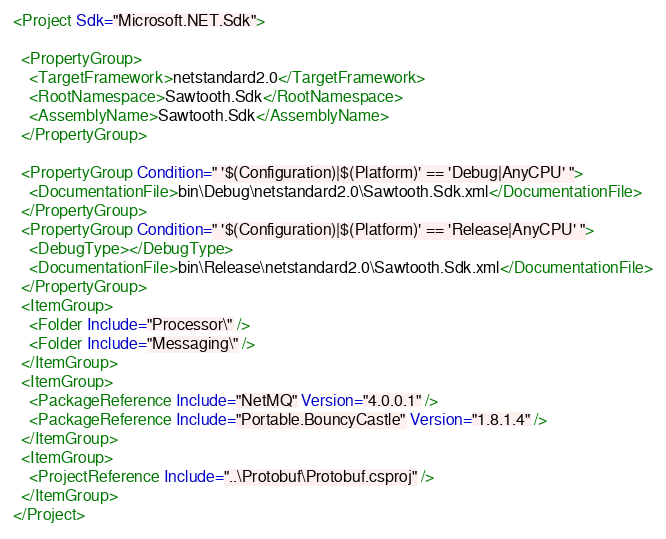<code> <loc_0><loc_0><loc_500><loc_500><_XML_><Project Sdk="Microsoft.NET.Sdk">

  <PropertyGroup>
    <TargetFramework>netstandard2.0</TargetFramework>
    <RootNamespace>Sawtooth.Sdk</RootNamespace>
    <AssemblyName>Sawtooth.Sdk</AssemblyName>
  </PropertyGroup>

  <PropertyGroup Condition=" '$(Configuration)|$(Platform)' == 'Debug|AnyCPU' ">
    <DocumentationFile>bin\Debug\netstandard2.0\Sawtooth.Sdk.xml</DocumentationFile>
  </PropertyGroup>
  <PropertyGroup Condition=" '$(Configuration)|$(Platform)' == 'Release|AnyCPU' ">
    <DebugType></DebugType>
    <DocumentationFile>bin\Release\netstandard2.0\Sawtooth.Sdk.xml</DocumentationFile>
  </PropertyGroup>
  <ItemGroup>
    <Folder Include="Processor\" />
    <Folder Include="Messaging\" />
  </ItemGroup>
  <ItemGroup>
    <PackageReference Include="NetMQ" Version="4.0.0.1" />
    <PackageReference Include="Portable.BouncyCastle" Version="1.8.1.4" />
  </ItemGroup>
  <ItemGroup>
    <ProjectReference Include="..\Protobuf\Protobuf.csproj" />
  </ItemGroup>
</Project>
</code> 